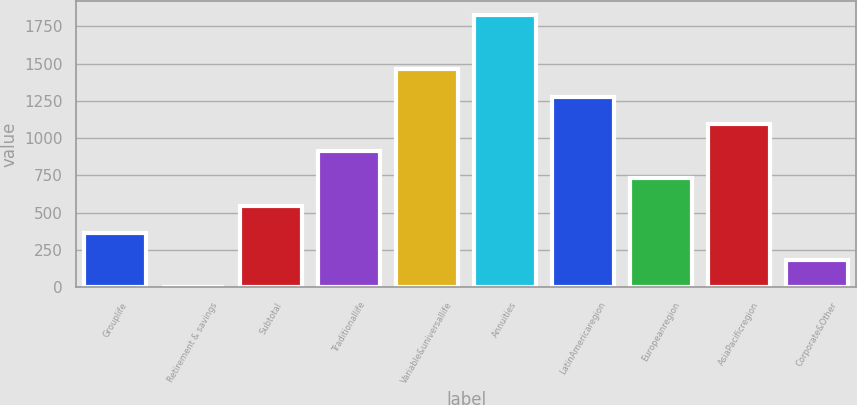<chart> <loc_0><loc_0><loc_500><loc_500><bar_chart><fcel>Grouplife<fcel>Retirement & savings<fcel>Subtotal<fcel>Traditionallife<fcel>Variable&universallife<fcel>Annuities<fcel>LatinAmericaregion<fcel>Europeanregion<fcel>AsiaPacificregion<fcel>Corporate&Other<nl><fcel>365.8<fcel>1<fcel>548.2<fcel>913<fcel>1460.2<fcel>1825<fcel>1277.8<fcel>730.6<fcel>1095.4<fcel>183.4<nl></chart> 